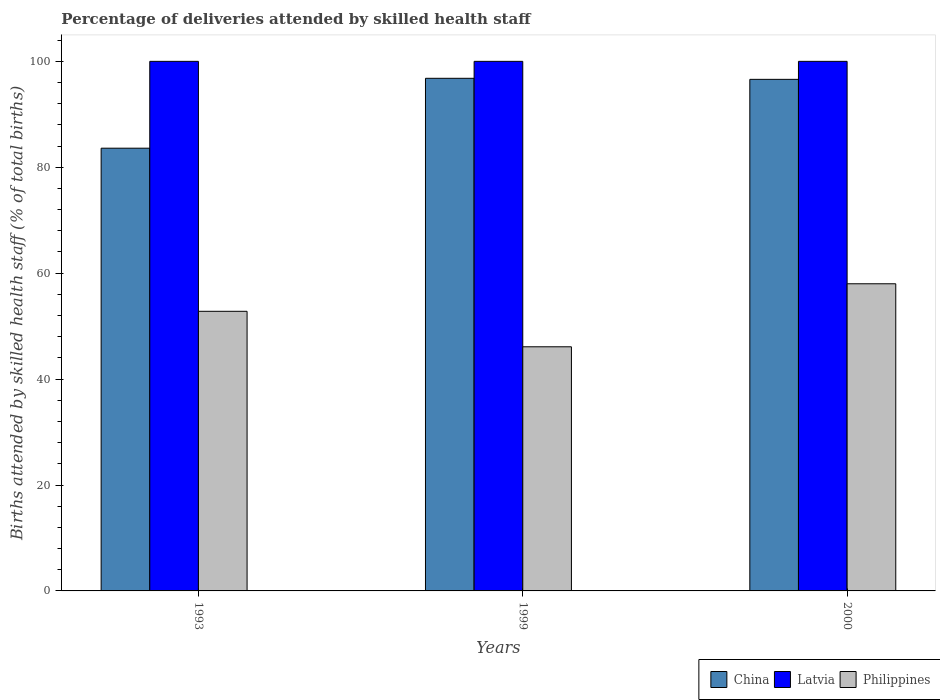How many groups of bars are there?
Ensure brevity in your answer.  3. Are the number of bars per tick equal to the number of legend labels?
Keep it short and to the point. Yes. How many bars are there on the 3rd tick from the left?
Offer a terse response. 3. What is the percentage of births attended by skilled health staff in Philippines in 1993?
Offer a terse response. 52.8. Across all years, what is the minimum percentage of births attended by skilled health staff in Philippines?
Your answer should be very brief. 46.1. In which year was the percentage of births attended by skilled health staff in Latvia maximum?
Your answer should be very brief. 1993. In which year was the percentage of births attended by skilled health staff in Latvia minimum?
Keep it short and to the point. 1993. What is the total percentage of births attended by skilled health staff in Latvia in the graph?
Give a very brief answer. 300. What is the difference between the percentage of births attended by skilled health staff in Philippines in 1993 and that in 1999?
Your answer should be very brief. 6.7. What is the difference between the percentage of births attended by skilled health staff in Philippines in 1993 and the percentage of births attended by skilled health staff in China in 1999?
Provide a succinct answer. -44. What is the average percentage of births attended by skilled health staff in Latvia per year?
Give a very brief answer. 100. In the year 2000, what is the difference between the percentage of births attended by skilled health staff in Latvia and percentage of births attended by skilled health staff in Philippines?
Your response must be concise. 42. In how many years, is the percentage of births attended by skilled health staff in Philippines greater than 32 %?
Your answer should be compact. 3. What is the difference between the highest and the second highest percentage of births attended by skilled health staff in China?
Your answer should be compact. 0.2. In how many years, is the percentage of births attended by skilled health staff in China greater than the average percentage of births attended by skilled health staff in China taken over all years?
Your response must be concise. 2. Is the sum of the percentage of births attended by skilled health staff in China in 1993 and 2000 greater than the maximum percentage of births attended by skilled health staff in Latvia across all years?
Make the answer very short. Yes. What does the 3rd bar from the left in 1999 represents?
Keep it short and to the point. Philippines. What does the 2nd bar from the right in 1999 represents?
Provide a succinct answer. Latvia. How many bars are there?
Make the answer very short. 9. Are all the bars in the graph horizontal?
Your answer should be very brief. No. Are the values on the major ticks of Y-axis written in scientific E-notation?
Provide a succinct answer. No. How are the legend labels stacked?
Offer a very short reply. Horizontal. What is the title of the graph?
Provide a short and direct response. Percentage of deliveries attended by skilled health staff. What is the label or title of the Y-axis?
Give a very brief answer. Births attended by skilled health staff (% of total births). What is the Births attended by skilled health staff (% of total births) of China in 1993?
Your response must be concise. 83.6. What is the Births attended by skilled health staff (% of total births) of Philippines in 1993?
Provide a short and direct response. 52.8. What is the Births attended by skilled health staff (% of total births) of China in 1999?
Your answer should be compact. 96.8. What is the Births attended by skilled health staff (% of total births) in Philippines in 1999?
Your response must be concise. 46.1. What is the Births attended by skilled health staff (% of total births) in China in 2000?
Keep it short and to the point. 96.6. Across all years, what is the maximum Births attended by skilled health staff (% of total births) of China?
Keep it short and to the point. 96.8. Across all years, what is the maximum Births attended by skilled health staff (% of total births) in Latvia?
Your answer should be compact. 100. Across all years, what is the minimum Births attended by skilled health staff (% of total births) of China?
Your response must be concise. 83.6. Across all years, what is the minimum Births attended by skilled health staff (% of total births) in Latvia?
Your answer should be compact. 100. Across all years, what is the minimum Births attended by skilled health staff (% of total births) of Philippines?
Offer a very short reply. 46.1. What is the total Births attended by skilled health staff (% of total births) of China in the graph?
Your response must be concise. 277. What is the total Births attended by skilled health staff (% of total births) in Latvia in the graph?
Your answer should be very brief. 300. What is the total Births attended by skilled health staff (% of total births) in Philippines in the graph?
Offer a very short reply. 156.9. What is the difference between the Births attended by skilled health staff (% of total births) of China in 1993 and that in 1999?
Your response must be concise. -13.2. What is the difference between the Births attended by skilled health staff (% of total births) of Philippines in 1993 and that in 1999?
Offer a very short reply. 6.7. What is the difference between the Births attended by skilled health staff (% of total births) in China in 1999 and that in 2000?
Offer a terse response. 0.2. What is the difference between the Births attended by skilled health staff (% of total births) in Latvia in 1999 and that in 2000?
Provide a succinct answer. 0. What is the difference between the Births attended by skilled health staff (% of total births) in Philippines in 1999 and that in 2000?
Make the answer very short. -11.9. What is the difference between the Births attended by skilled health staff (% of total births) of China in 1993 and the Births attended by skilled health staff (% of total births) of Latvia in 1999?
Keep it short and to the point. -16.4. What is the difference between the Births attended by skilled health staff (% of total births) of China in 1993 and the Births attended by skilled health staff (% of total births) of Philippines in 1999?
Provide a short and direct response. 37.5. What is the difference between the Births attended by skilled health staff (% of total births) of Latvia in 1993 and the Births attended by skilled health staff (% of total births) of Philippines in 1999?
Ensure brevity in your answer.  53.9. What is the difference between the Births attended by skilled health staff (% of total births) of China in 1993 and the Births attended by skilled health staff (% of total births) of Latvia in 2000?
Your answer should be very brief. -16.4. What is the difference between the Births attended by skilled health staff (% of total births) of China in 1993 and the Births attended by skilled health staff (% of total births) of Philippines in 2000?
Offer a terse response. 25.6. What is the difference between the Births attended by skilled health staff (% of total births) in Latvia in 1993 and the Births attended by skilled health staff (% of total births) in Philippines in 2000?
Provide a short and direct response. 42. What is the difference between the Births attended by skilled health staff (% of total births) in China in 1999 and the Births attended by skilled health staff (% of total births) in Philippines in 2000?
Your answer should be compact. 38.8. What is the difference between the Births attended by skilled health staff (% of total births) in Latvia in 1999 and the Births attended by skilled health staff (% of total births) in Philippines in 2000?
Your answer should be very brief. 42. What is the average Births attended by skilled health staff (% of total births) in China per year?
Provide a succinct answer. 92.33. What is the average Births attended by skilled health staff (% of total births) in Philippines per year?
Your response must be concise. 52.3. In the year 1993, what is the difference between the Births attended by skilled health staff (% of total births) of China and Births attended by skilled health staff (% of total births) of Latvia?
Provide a succinct answer. -16.4. In the year 1993, what is the difference between the Births attended by skilled health staff (% of total births) in China and Births attended by skilled health staff (% of total births) in Philippines?
Your answer should be very brief. 30.8. In the year 1993, what is the difference between the Births attended by skilled health staff (% of total births) in Latvia and Births attended by skilled health staff (% of total births) in Philippines?
Your answer should be very brief. 47.2. In the year 1999, what is the difference between the Births attended by skilled health staff (% of total births) in China and Births attended by skilled health staff (% of total births) in Latvia?
Ensure brevity in your answer.  -3.2. In the year 1999, what is the difference between the Births attended by skilled health staff (% of total births) of China and Births attended by skilled health staff (% of total births) of Philippines?
Make the answer very short. 50.7. In the year 1999, what is the difference between the Births attended by skilled health staff (% of total births) of Latvia and Births attended by skilled health staff (% of total births) of Philippines?
Offer a very short reply. 53.9. In the year 2000, what is the difference between the Births attended by skilled health staff (% of total births) of China and Births attended by skilled health staff (% of total births) of Latvia?
Give a very brief answer. -3.4. In the year 2000, what is the difference between the Births attended by skilled health staff (% of total births) in China and Births attended by skilled health staff (% of total births) in Philippines?
Keep it short and to the point. 38.6. In the year 2000, what is the difference between the Births attended by skilled health staff (% of total births) of Latvia and Births attended by skilled health staff (% of total births) of Philippines?
Offer a terse response. 42. What is the ratio of the Births attended by skilled health staff (% of total births) in China in 1993 to that in 1999?
Your response must be concise. 0.86. What is the ratio of the Births attended by skilled health staff (% of total births) of Philippines in 1993 to that in 1999?
Your answer should be compact. 1.15. What is the ratio of the Births attended by skilled health staff (% of total births) of China in 1993 to that in 2000?
Your response must be concise. 0.87. What is the ratio of the Births attended by skilled health staff (% of total births) of Philippines in 1993 to that in 2000?
Offer a very short reply. 0.91. What is the ratio of the Births attended by skilled health staff (% of total births) of Latvia in 1999 to that in 2000?
Give a very brief answer. 1. What is the ratio of the Births attended by skilled health staff (% of total births) of Philippines in 1999 to that in 2000?
Your answer should be compact. 0.79. What is the difference between the highest and the second highest Births attended by skilled health staff (% of total births) of China?
Provide a short and direct response. 0.2. What is the difference between the highest and the second highest Births attended by skilled health staff (% of total births) of Philippines?
Offer a terse response. 5.2. What is the difference between the highest and the lowest Births attended by skilled health staff (% of total births) of China?
Provide a succinct answer. 13.2. What is the difference between the highest and the lowest Births attended by skilled health staff (% of total births) in Philippines?
Provide a succinct answer. 11.9. 